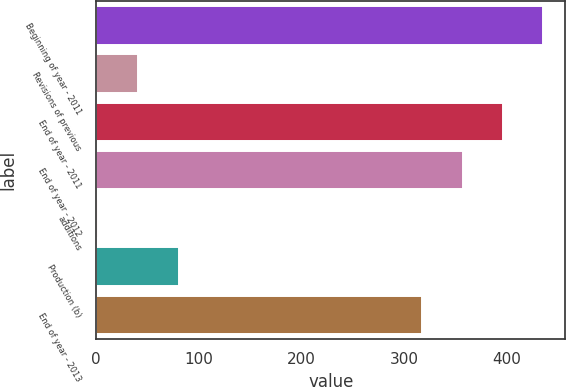Convert chart. <chart><loc_0><loc_0><loc_500><loc_500><bar_chart><fcel>Beginning of year - 2011<fcel>Revisions of previous<fcel>End of year - 2011<fcel>End of year - 2012<fcel>additions<fcel>Production (b)<fcel>End of year - 2013<nl><fcel>435.6<fcel>41.2<fcel>396.4<fcel>357.2<fcel>2<fcel>80.4<fcel>318<nl></chart> 